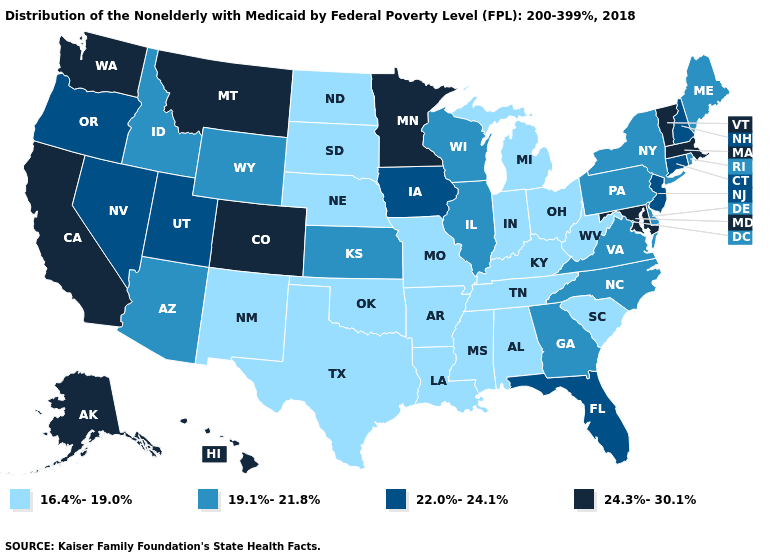Among the states that border Delaware , which have the lowest value?
Quick response, please. Pennsylvania. Does Massachusetts have the lowest value in the USA?
Quick response, please. No. Which states have the lowest value in the USA?
Short answer required. Alabama, Arkansas, Indiana, Kentucky, Louisiana, Michigan, Mississippi, Missouri, Nebraska, New Mexico, North Dakota, Ohio, Oklahoma, South Carolina, South Dakota, Tennessee, Texas, West Virginia. Which states have the lowest value in the West?
Quick response, please. New Mexico. What is the highest value in the USA?
Give a very brief answer. 24.3%-30.1%. What is the value of Kentucky?
Quick response, please. 16.4%-19.0%. What is the lowest value in the West?
Concise answer only. 16.4%-19.0%. What is the highest value in the West ?
Keep it brief. 24.3%-30.1%. Is the legend a continuous bar?
Write a very short answer. No. Among the states that border Ohio , does West Virginia have the highest value?
Answer briefly. No. What is the value of Louisiana?
Concise answer only. 16.4%-19.0%. What is the value of Delaware?
Be succinct. 19.1%-21.8%. What is the lowest value in the West?
Concise answer only. 16.4%-19.0%. What is the value of Kansas?
Be succinct. 19.1%-21.8%. Name the states that have a value in the range 24.3%-30.1%?
Short answer required. Alaska, California, Colorado, Hawaii, Maryland, Massachusetts, Minnesota, Montana, Vermont, Washington. 